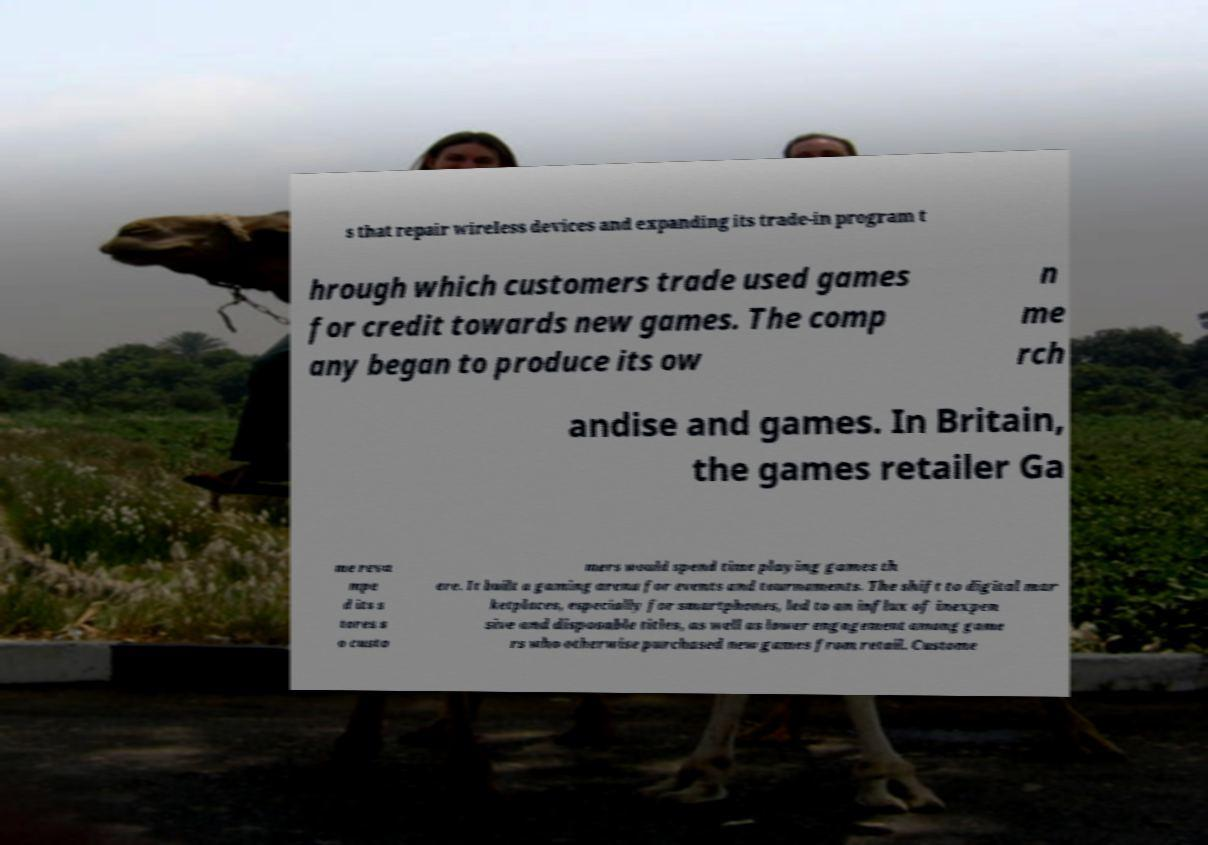Can you accurately transcribe the text from the provided image for me? s that repair wireless devices and expanding its trade-in program t hrough which customers trade used games for credit towards new games. The comp any began to produce its ow n me rch andise and games. In Britain, the games retailer Ga me reva mpe d its s tores s o custo mers would spend time playing games th ere. It built a gaming arena for events and tournaments. The shift to digital mar ketplaces, especially for smartphones, led to an influx of inexpen sive and disposable titles, as well as lower engagement among game rs who otherwise purchased new games from retail. Custome 